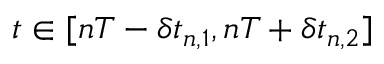<formula> <loc_0><loc_0><loc_500><loc_500>t \in [ n T - \delta t _ { n , 1 } , n T + \delta t _ { n , 2 } ]</formula> 